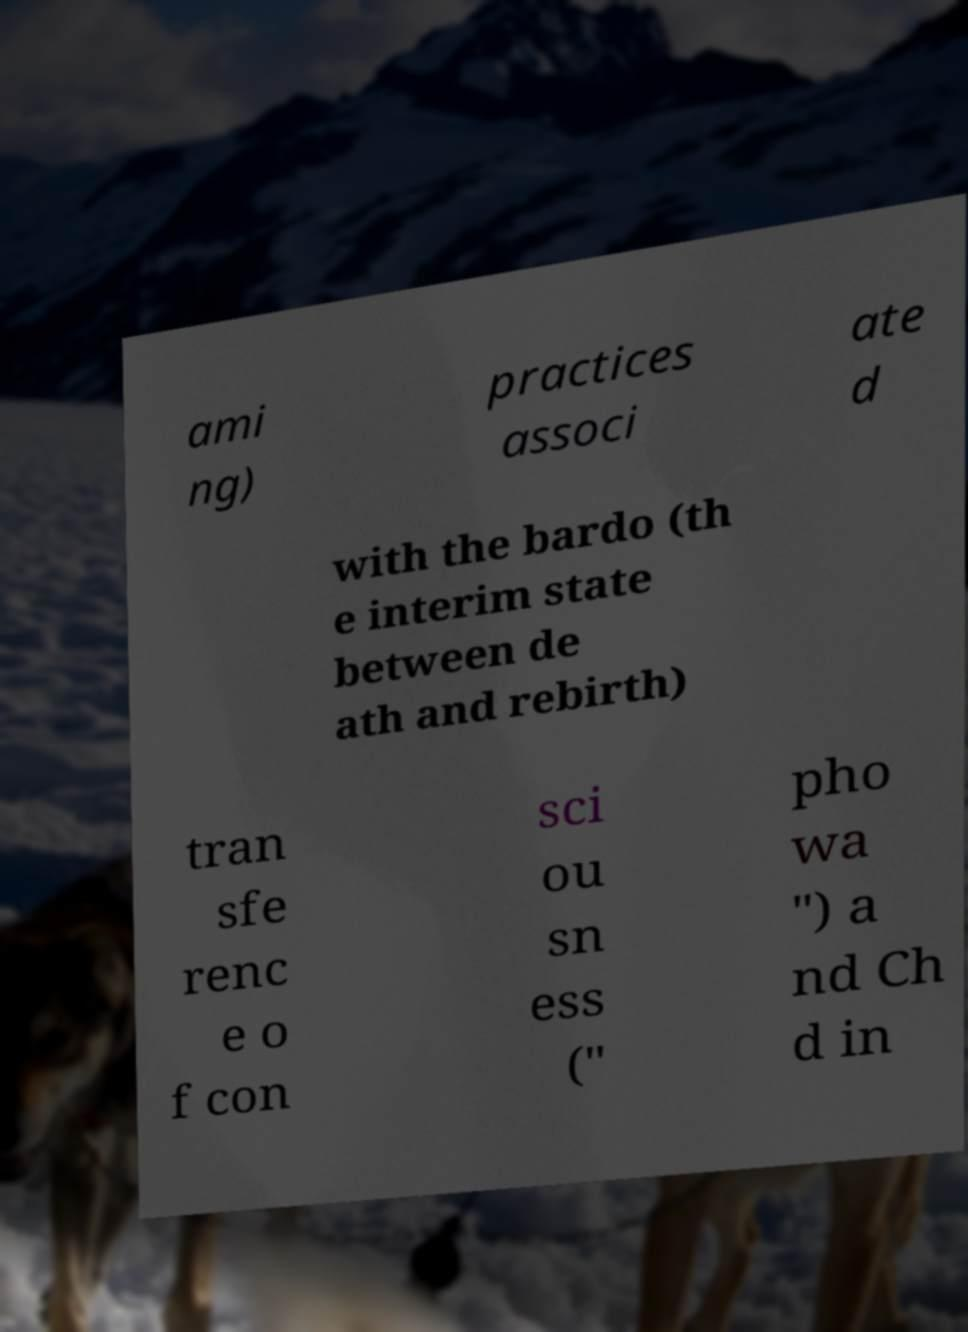Could you assist in decoding the text presented in this image and type it out clearly? ami ng) practices associ ate d with the bardo (th e interim state between de ath and rebirth) tran sfe renc e o f con sci ou sn ess (" pho wa ") a nd Ch d in 